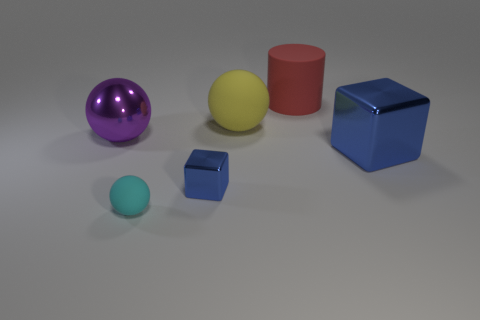There is a sphere in front of the purple metallic object; is it the same color as the large matte cylinder?
Give a very brief answer. No. Is the number of blue blocks on the left side of the small rubber object the same as the number of shiny balls in front of the purple metal object?
Offer a terse response. Yes. Is there anything else that has the same material as the yellow ball?
Your response must be concise. Yes. What color is the big rubber object that is to the right of the large rubber sphere?
Provide a short and direct response. Red. Are there the same number of blue shiny objects that are in front of the small shiny block and red things?
Offer a terse response. No. How many other things are there of the same shape as the large red thing?
Provide a succinct answer. 0. What number of blue objects are right of the rubber cylinder?
Provide a short and direct response. 1. There is a rubber object that is both behind the metallic sphere and in front of the red object; how big is it?
Offer a terse response. Large. Is there a blue ball?
Offer a terse response. No. What number of other things are there of the same size as the cyan sphere?
Offer a terse response. 1. 